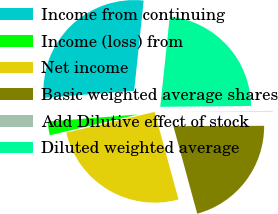<chart> <loc_0><loc_0><loc_500><loc_500><pie_chart><fcel>Income from continuing<fcel>Income (loss) from<fcel>Net income<fcel>Basic weighted average shares<fcel>Add Dilutive effect of stock<fcel>Diluted weighted average<nl><fcel>27.91%<fcel>2.44%<fcel>25.55%<fcel>20.83%<fcel>0.08%<fcel>23.19%<nl></chart> 